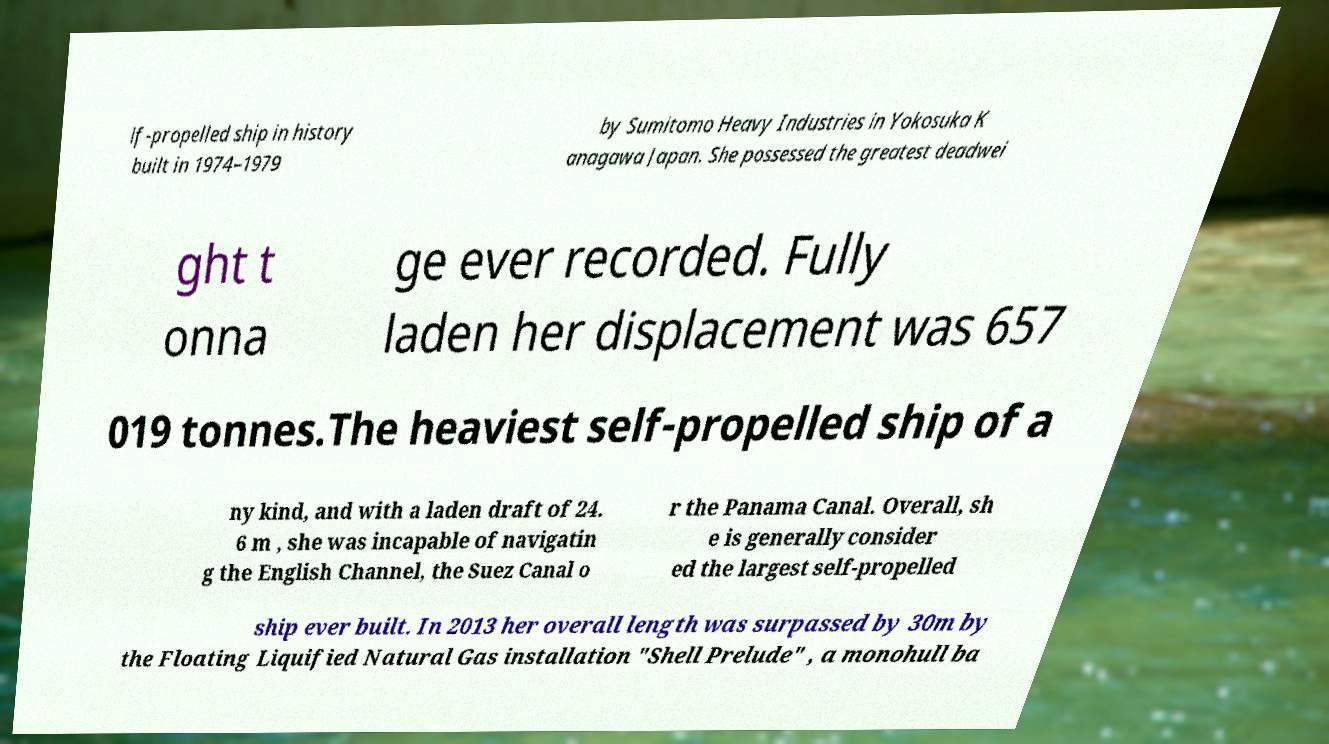There's text embedded in this image that I need extracted. Can you transcribe it verbatim? lf-propelled ship in history built in 1974–1979 by Sumitomo Heavy Industries in Yokosuka K anagawa Japan. She possessed the greatest deadwei ght t onna ge ever recorded. Fully laden her displacement was 657 019 tonnes.The heaviest self-propelled ship of a ny kind, and with a laden draft of 24. 6 m , she was incapable of navigatin g the English Channel, the Suez Canal o r the Panama Canal. Overall, sh e is generally consider ed the largest self-propelled ship ever built. In 2013 her overall length was surpassed by 30m by the Floating Liquified Natural Gas installation "Shell Prelude" , a monohull ba 